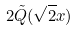<formula> <loc_0><loc_0><loc_500><loc_500>2 { \tilde { Q } } ( { \sqrt { 2 } } x )</formula> 